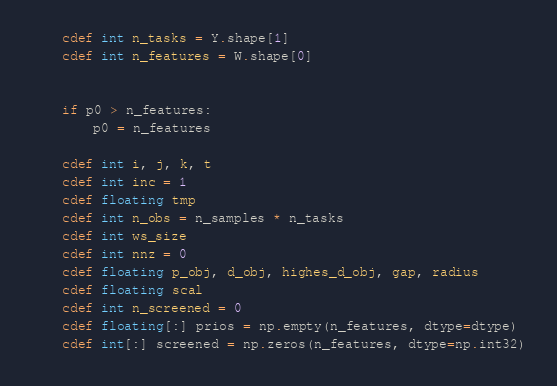Convert code to text. <code><loc_0><loc_0><loc_500><loc_500><_Cython_>    cdef int n_tasks = Y.shape[1]
    cdef int n_features = W.shape[0]


    if p0 > n_features:
        p0 = n_features

    cdef int i, j, k, t
    cdef int inc = 1
    cdef floating tmp
    cdef int n_obs = n_samples * n_tasks
    cdef int ws_size
    cdef int nnz = 0
    cdef floating p_obj, d_obj, highes_d_obj, gap, radius
    cdef floating scal
    cdef int n_screened = 0
    cdef floating[:] prios = np.empty(n_features, dtype=dtype)
    cdef int[:] screened = np.zeros(n_features, dtype=np.int32)</code> 